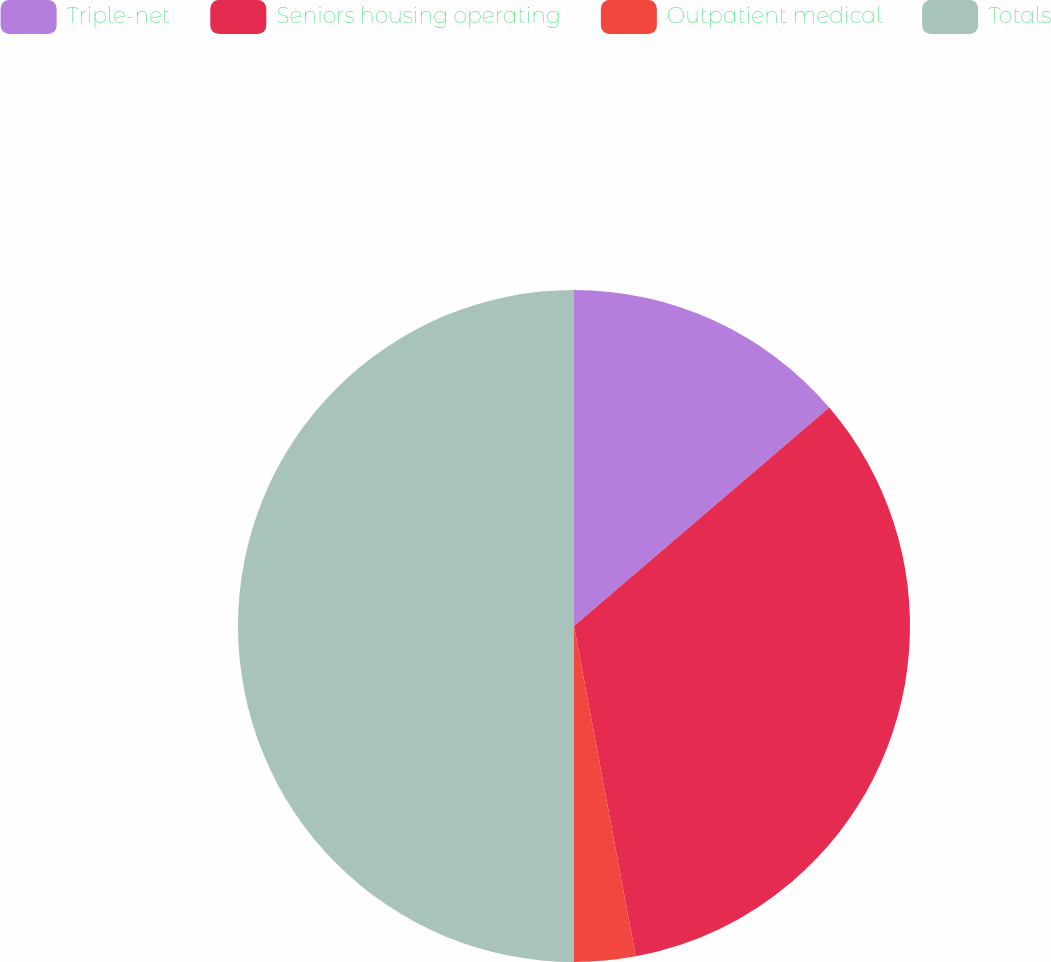Convert chart to OTSL. <chart><loc_0><loc_0><loc_500><loc_500><pie_chart><fcel>Triple-net<fcel>Seniors housing operating<fcel>Outpatient medical<fcel>Totals<nl><fcel>13.73%<fcel>33.33%<fcel>2.94%<fcel>50.0%<nl></chart> 